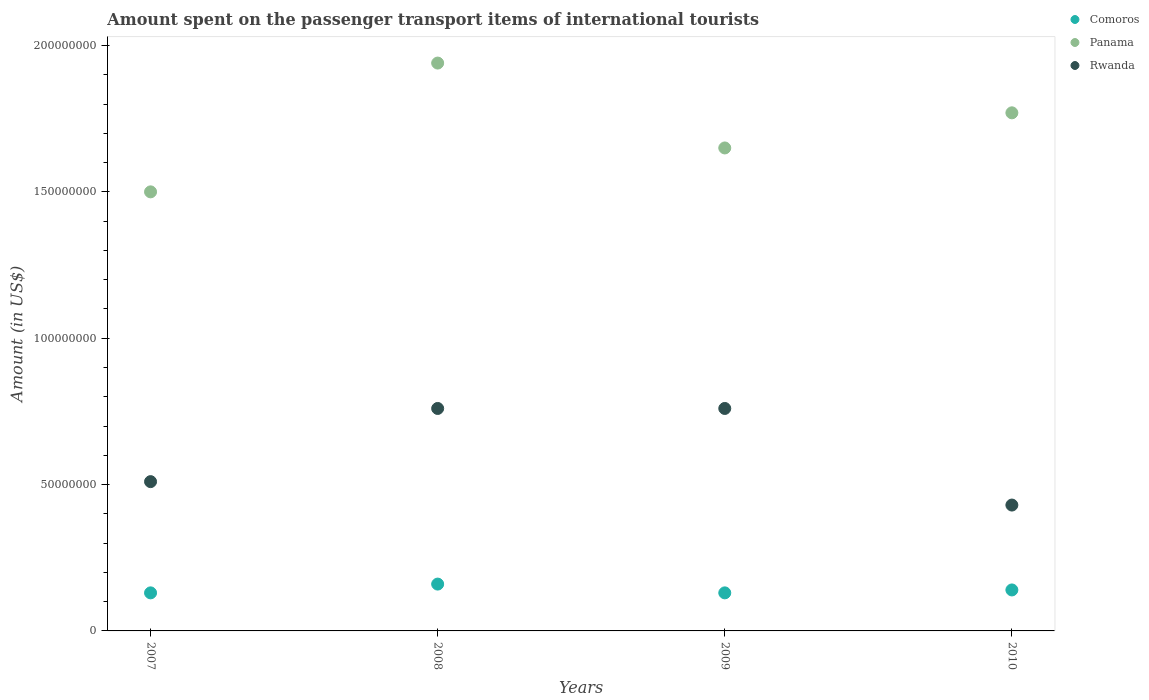How many different coloured dotlines are there?
Offer a very short reply. 3. What is the amount spent on the passenger transport items of international tourists in Rwanda in 2007?
Ensure brevity in your answer.  5.10e+07. Across all years, what is the maximum amount spent on the passenger transport items of international tourists in Comoros?
Offer a very short reply. 1.60e+07. Across all years, what is the minimum amount spent on the passenger transport items of international tourists in Rwanda?
Provide a short and direct response. 4.30e+07. In which year was the amount spent on the passenger transport items of international tourists in Panama maximum?
Your response must be concise. 2008. In which year was the amount spent on the passenger transport items of international tourists in Rwanda minimum?
Make the answer very short. 2010. What is the total amount spent on the passenger transport items of international tourists in Panama in the graph?
Your answer should be very brief. 6.86e+08. What is the difference between the amount spent on the passenger transport items of international tourists in Comoros in 2007 and that in 2009?
Provide a short and direct response. 0. What is the difference between the amount spent on the passenger transport items of international tourists in Panama in 2007 and the amount spent on the passenger transport items of international tourists in Rwanda in 2009?
Make the answer very short. 7.40e+07. What is the average amount spent on the passenger transport items of international tourists in Rwanda per year?
Give a very brief answer. 6.15e+07. In the year 2008, what is the difference between the amount spent on the passenger transport items of international tourists in Panama and amount spent on the passenger transport items of international tourists in Comoros?
Ensure brevity in your answer.  1.78e+08. What is the ratio of the amount spent on the passenger transport items of international tourists in Rwanda in 2009 to that in 2010?
Your response must be concise. 1.77. What is the difference between the highest and the lowest amount spent on the passenger transport items of international tourists in Comoros?
Your response must be concise. 3.00e+06. Is the sum of the amount spent on the passenger transport items of international tourists in Rwanda in 2007 and 2008 greater than the maximum amount spent on the passenger transport items of international tourists in Panama across all years?
Offer a very short reply. No. How many dotlines are there?
Provide a short and direct response. 3. What is the difference between two consecutive major ticks on the Y-axis?
Keep it short and to the point. 5.00e+07. Does the graph contain grids?
Your answer should be very brief. No. What is the title of the graph?
Ensure brevity in your answer.  Amount spent on the passenger transport items of international tourists. Does "Egypt, Arab Rep." appear as one of the legend labels in the graph?
Provide a short and direct response. No. What is the label or title of the X-axis?
Offer a very short reply. Years. What is the label or title of the Y-axis?
Your answer should be very brief. Amount (in US$). What is the Amount (in US$) in Comoros in 2007?
Make the answer very short. 1.30e+07. What is the Amount (in US$) in Panama in 2007?
Your answer should be compact. 1.50e+08. What is the Amount (in US$) in Rwanda in 2007?
Keep it short and to the point. 5.10e+07. What is the Amount (in US$) of Comoros in 2008?
Provide a short and direct response. 1.60e+07. What is the Amount (in US$) of Panama in 2008?
Keep it short and to the point. 1.94e+08. What is the Amount (in US$) of Rwanda in 2008?
Make the answer very short. 7.60e+07. What is the Amount (in US$) of Comoros in 2009?
Offer a very short reply. 1.30e+07. What is the Amount (in US$) in Panama in 2009?
Your answer should be compact. 1.65e+08. What is the Amount (in US$) of Rwanda in 2009?
Make the answer very short. 7.60e+07. What is the Amount (in US$) in Comoros in 2010?
Keep it short and to the point. 1.40e+07. What is the Amount (in US$) in Panama in 2010?
Your answer should be very brief. 1.77e+08. What is the Amount (in US$) of Rwanda in 2010?
Provide a succinct answer. 4.30e+07. Across all years, what is the maximum Amount (in US$) in Comoros?
Provide a succinct answer. 1.60e+07. Across all years, what is the maximum Amount (in US$) in Panama?
Your response must be concise. 1.94e+08. Across all years, what is the maximum Amount (in US$) of Rwanda?
Your answer should be compact. 7.60e+07. Across all years, what is the minimum Amount (in US$) in Comoros?
Your answer should be very brief. 1.30e+07. Across all years, what is the minimum Amount (in US$) in Panama?
Ensure brevity in your answer.  1.50e+08. Across all years, what is the minimum Amount (in US$) in Rwanda?
Make the answer very short. 4.30e+07. What is the total Amount (in US$) in Comoros in the graph?
Offer a very short reply. 5.60e+07. What is the total Amount (in US$) in Panama in the graph?
Your answer should be compact. 6.86e+08. What is the total Amount (in US$) in Rwanda in the graph?
Provide a short and direct response. 2.46e+08. What is the difference between the Amount (in US$) of Comoros in 2007 and that in 2008?
Your answer should be very brief. -3.00e+06. What is the difference between the Amount (in US$) of Panama in 2007 and that in 2008?
Offer a terse response. -4.40e+07. What is the difference between the Amount (in US$) in Rwanda in 2007 and that in 2008?
Provide a short and direct response. -2.50e+07. What is the difference between the Amount (in US$) of Comoros in 2007 and that in 2009?
Keep it short and to the point. 0. What is the difference between the Amount (in US$) in Panama in 2007 and that in 2009?
Give a very brief answer. -1.50e+07. What is the difference between the Amount (in US$) of Rwanda in 2007 and that in 2009?
Your response must be concise. -2.50e+07. What is the difference between the Amount (in US$) in Panama in 2007 and that in 2010?
Offer a very short reply. -2.70e+07. What is the difference between the Amount (in US$) in Comoros in 2008 and that in 2009?
Your response must be concise. 3.00e+06. What is the difference between the Amount (in US$) of Panama in 2008 and that in 2009?
Give a very brief answer. 2.90e+07. What is the difference between the Amount (in US$) in Rwanda in 2008 and that in 2009?
Provide a succinct answer. 0. What is the difference between the Amount (in US$) in Panama in 2008 and that in 2010?
Provide a short and direct response. 1.70e+07. What is the difference between the Amount (in US$) in Rwanda in 2008 and that in 2010?
Offer a very short reply. 3.30e+07. What is the difference between the Amount (in US$) in Panama in 2009 and that in 2010?
Ensure brevity in your answer.  -1.20e+07. What is the difference between the Amount (in US$) of Rwanda in 2009 and that in 2010?
Provide a succinct answer. 3.30e+07. What is the difference between the Amount (in US$) in Comoros in 2007 and the Amount (in US$) in Panama in 2008?
Provide a short and direct response. -1.81e+08. What is the difference between the Amount (in US$) of Comoros in 2007 and the Amount (in US$) of Rwanda in 2008?
Offer a very short reply. -6.30e+07. What is the difference between the Amount (in US$) in Panama in 2007 and the Amount (in US$) in Rwanda in 2008?
Provide a short and direct response. 7.40e+07. What is the difference between the Amount (in US$) in Comoros in 2007 and the Amount (in US$) in Panama in 2009?
Make the answer very short. -1.52e+08. What is the difference between the Amount (in US$) of Comoros in 2007 and the Amount (in US$) of Rwanda in 2009?
Keep it short and to the point. -6.30e+07. What is the difference between the Amount (in US$) of Panama in 2007 and the Amount (in US$) of Rwanda in 2009?
Offer a very short reply. 7.40e+07. What is the difference between the Amount (in US$) in Comoros in 2007 and the Amount (in US$) in Panama in 2010?
Offer a very short reply. -1.64e+08. What is the difference between the Amount (in US$) of Comoros in 2007 and the Amount (in US$) of Rwanda in 2010?
Offer a very short reply. -3.00e+07. What is the difference between the Amount (in US$) of Panama in 2007 and the Amount (in US$) of Rwanda in 2010?
Your response must be concise. 1.07e+08. What is the difference between the Amount (in US$) of Comoros in 2008 and the Amount (in US$) of Panama in 2009?
Offer a very short reply. -1.49e+08. What is the difference between the Amount (in US$) in Comoros in 2008 and the Amount (in US$) in Rwanda in 2009?
Provide a succinct answer. -6.00e+07. What is the difference between the Amount (in US$) in Panama in 2008 and the Amount (in US$) in Rwanda in 2009?
Keep it short and to the point. 1.18e+08. What is the difference between the Amount (in US$) in Comoros in 2008 and the Amount (in US$) in Panama in 2010?
Your answer should be compact. -1.61e+08. What is the difference between the Amount (in US$) in Comoros in 2008 and the Amount (in US$) in Rwanda in 2010?
Offer a very short reply. -2.70e+07. What is the difference between the Amount (in US$) of Panama in 2008 and the Amount (in US$) of Rwanda in 2010?
Provide a short and direct response. 1.51e+08. What is the difference between the Amount (in US$) in Comoros in 2009 and the Amount (in US$) in Panama in 2010?
Provide a short and direct response. -1.64e+08. What is the difference between the Amount (in US$) in Comoros in 2009 and the Amount (in US$) in Rwanda in 2010?
Ensure brevity in your answer.  -3.00e+07. What is the difference between the Amount (in US$) in Panama in 2009 and the Amount (in US$) in Rwanda in 2010?
Ensure brevity in your answer.  1.22e+08. What is the average Amount (in US$) of Comoros per year?
Provide a succinct answer. 1.40e+07. What is the average Amount (in US$) of Panama per year?
Your answer should be compact. 1.72e+08. What is the average Amount (in US$) of Rwanda per year?
Keep it short and to the point. 6.15e+07. In the year 2007, what is the difference between the Amount (in US$) of Comoros and Amount (in US$) of Panama?
Offer a terse response. -1.37e+08. In the year 2007, what is the difference between the Amount (in US$) in Comoros and Amount (in US$) in Rwanda?
Give a very brief answer. -3.80e+07. In the year 2007, what is the difference between the Amount (in US$) in Panama and Amount (in US$) in Rwanda?
Keep it short and to the point. 9.90e+07. In the year 2008, what is the difference between the Amount (in US$) of Comoros and Amount (in US$) of Panama?
Your answer should be compact. -1.78e+08. In the year 2008, what is the difference between the Amount (in US$) in Comoros and Amount (in US$) in Rwanda?
Provide a short and direct response. -6.00e+07. In the year 2008, what is the difference between the Amount (in US$) in Panama and Amount (in US$) in Rwanda?
Your answer should be very brief. 1.18e+08. In the year 2009, what is the difference between the Amount (in US$) of Comoros and Amount (in US$) of Panama?
Keep it short and to the point. -1.52e+08. In the year 2009, what is the difference between the Amount (in US$) in Comoros and Amount (in US$) in Rwanda?
Ensure brevity in your answer.  -6.30e+07. In the year 2009, what is the difference between the Amount (in US$) in Panama and Amount (in US$) in Rwanda?
Make the answer very short. 8.90e+07. In the year 2010, what is the difference between the Amount (in US$) of Comoros and Amount (in US$) of Panama?
Ensure brevity in your answer.  -1.63e+08. In the year 2010, what is the difference between the Amount (in US$) of Comoros and Amount (in US$) of Rwanda?
Your answer should be compact. -2.90e+07. In the year 2010, what is the difference between the Amount (in US$) in Panama and Amount (in US$) in Rwanda?
Your response must be concise. 1.34e+08. What is the ratio of the Amount (in US$) of Comoros in 2007 to that in 2008?
Offer a terse response. 0.81. What is the ratio of the Amount (in US$) in Panama in 2007 to that in 2008?
Your answer should be very brief. 0.77. What is the ratio of the Amount (in US$) of Rwanda in 2007 to that in 2008?
Make the answer very short. 0.67. What is the ratio of the Amount (in US$) of Comoros in 2007 to that in 2009?
Ensure brevity in your answer.  1. What is the ratio of the Amount (in US$) of Rwanda in 2007 to that in 2009?
Your response must be concise. 0.67. What is the ratio of the Amount (in US$) of Comoros in 2007 to that in 2010?
Make the answer very short. 0.93. What is the ratio of the Amount (in US$) of Panama in 2007 to that in 2010?
Ensure brevity in your answer.  0.85. What is the ratio of the Amount (in US$) in Rwanda in 2007 to that in 2010?
Give a very brief answer. 1.19. What is the ratio of the Amount (in US$) of Comoros in 2008 to that in 2009?
Provide a succinct answer. 1.23. What is the ratio of the Amount (in US$) of Panama in 2008 to that in 2009?
Provide a short and direct response. 1.18. What is the ratio of the Amount (in US$) in Rwanda in 2008 to that in 2009?
Provide a succinct answer. 1. What is the ratio of the Amount (in US$) in Comoros in 2008 to that in 2010?
Ensure brevity in your answer.  1.14. What is the ratio of the Amount (in US$) of Panama in 2008 to that in 2010?
Offer a terse response. 1.1. What is the ratio of the Amount (in US$) of Rwanda in 2008 to that in 2010?
Ensure brevity in your answer.  1.77. What is the ratio of the Amount (in US$) of Comoros in 2009 to that in 2010?
Offer a terse response. 0.93. What is the ratio of the Amount (in US$) in Panama in 2009 to that in 2010?
Your response must be concise. 0.93. What is the ratio of the Amount (in US$) in Rwanda in 2009 to that in 2010?
Offer a terse response. 1.77. What is the difference between the highest and the second highest Amount (in US$) in Comoros?
Make the answer very short. 2.00e+06. What is the difference between the highest and the second highest Amount (in US$) in Panama?
Offer a terse response. 1.70e+07. What is the difference between the highest and the second highest Amount (in US$) of Rwanda?
Your answer should be very brief. 0. What is the difference between the highest and the lowest Amount (in US$) in Comoros?
Your answer should be compact. 3.00e+06. What is the difference between the highest and the lowest Amount (in US$) in Panama?
Provide a short and direct response. 4.40e+07. What is the difference between the highest and the lowest Amount (in US$) in Rwanda?
Offer a very short reply. 3.30e+07. 